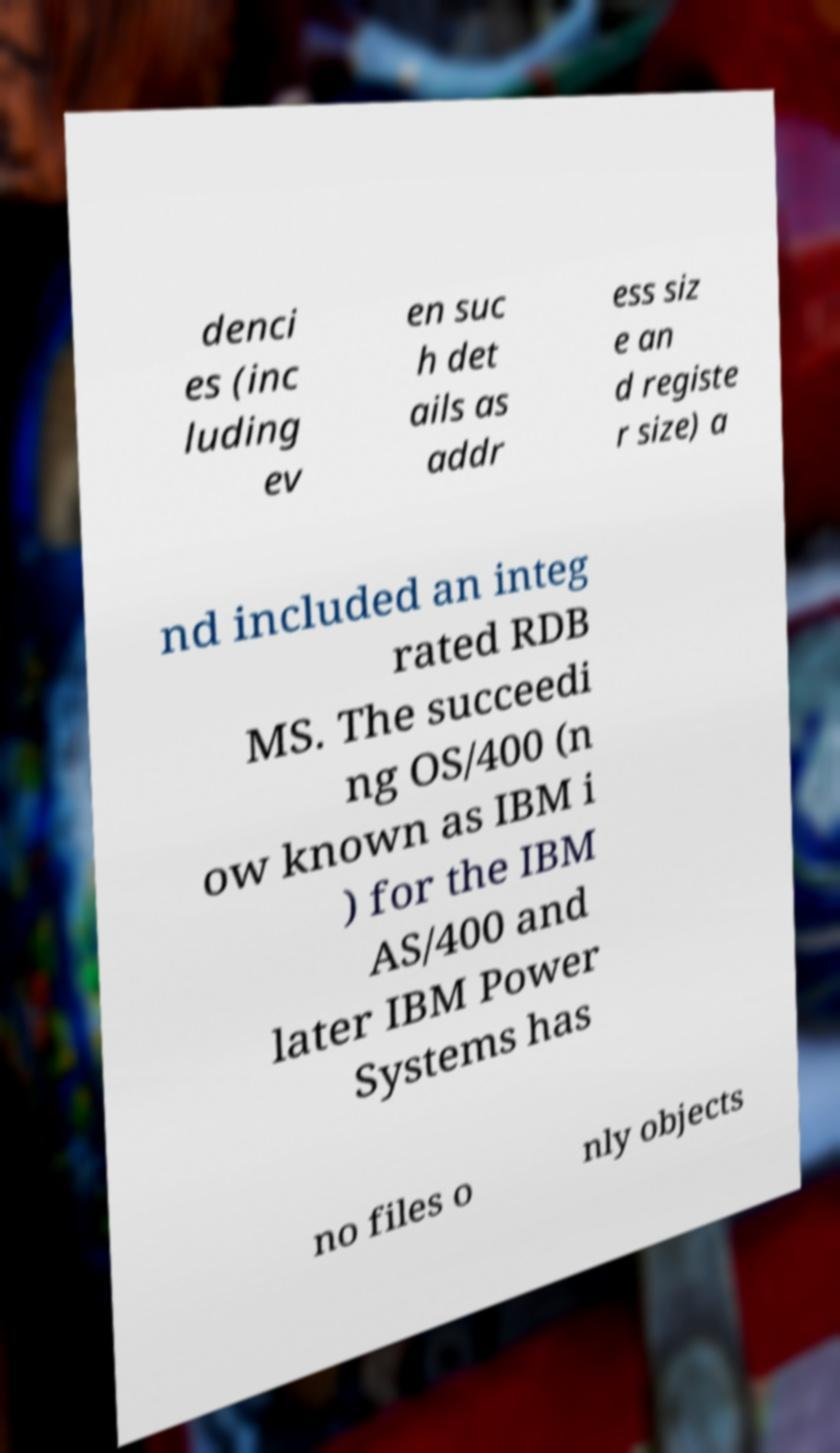Can you accurately transcribe the text from the provided image for me? denci es (inc luding ev en suc h det ails as addr ess siz e an d registe r size) a nd included an integ rated RDB MS. The succeedi ng OS/400 (n ow known as IBM i ) for the IBM AS/400 and later IBM Power Systems has no files o nly objects 